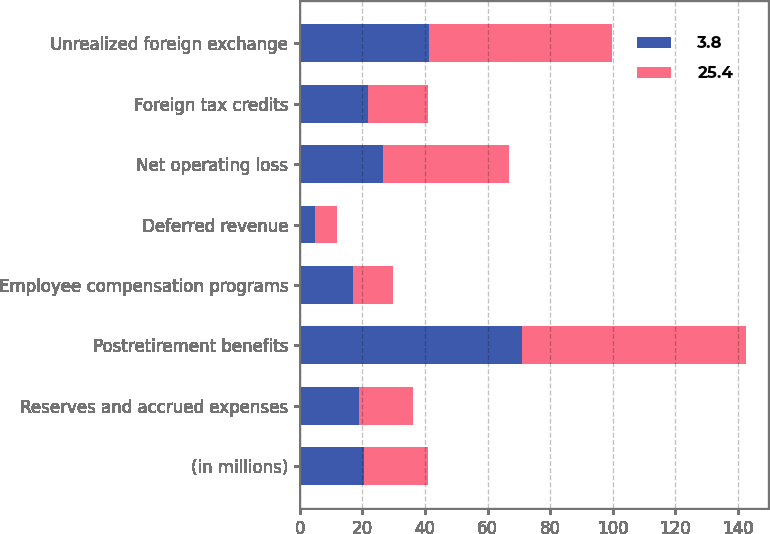<chart> <loc_0><loc_0><loc_500><loc_500><stacked_bar_chart><ecel><fcel>(in millions)<fcel>Reserves and accrued expenses<fcel>Postretirement benefits<fcel>Employee compensation programs<fcel>Deferred revenue<fcel>Net operating loss<fcel>Foreign tax credits<fcel>Unrealized foreign exchange<nl><fcel>3.8<fcel>20.5<fcel>18.9<fcel>71.1<fcel>17.1<fcel>4.8<fcel>26.7<fcel>21.9<fcel>41.4<nl><fcel>25.4<fcel>20.5<fcel>17.1<fcel>71.5<fcel>12.6<fcel>7<fcel>40.1<fcel>19.1<fcel>58.5<nl></chart> 